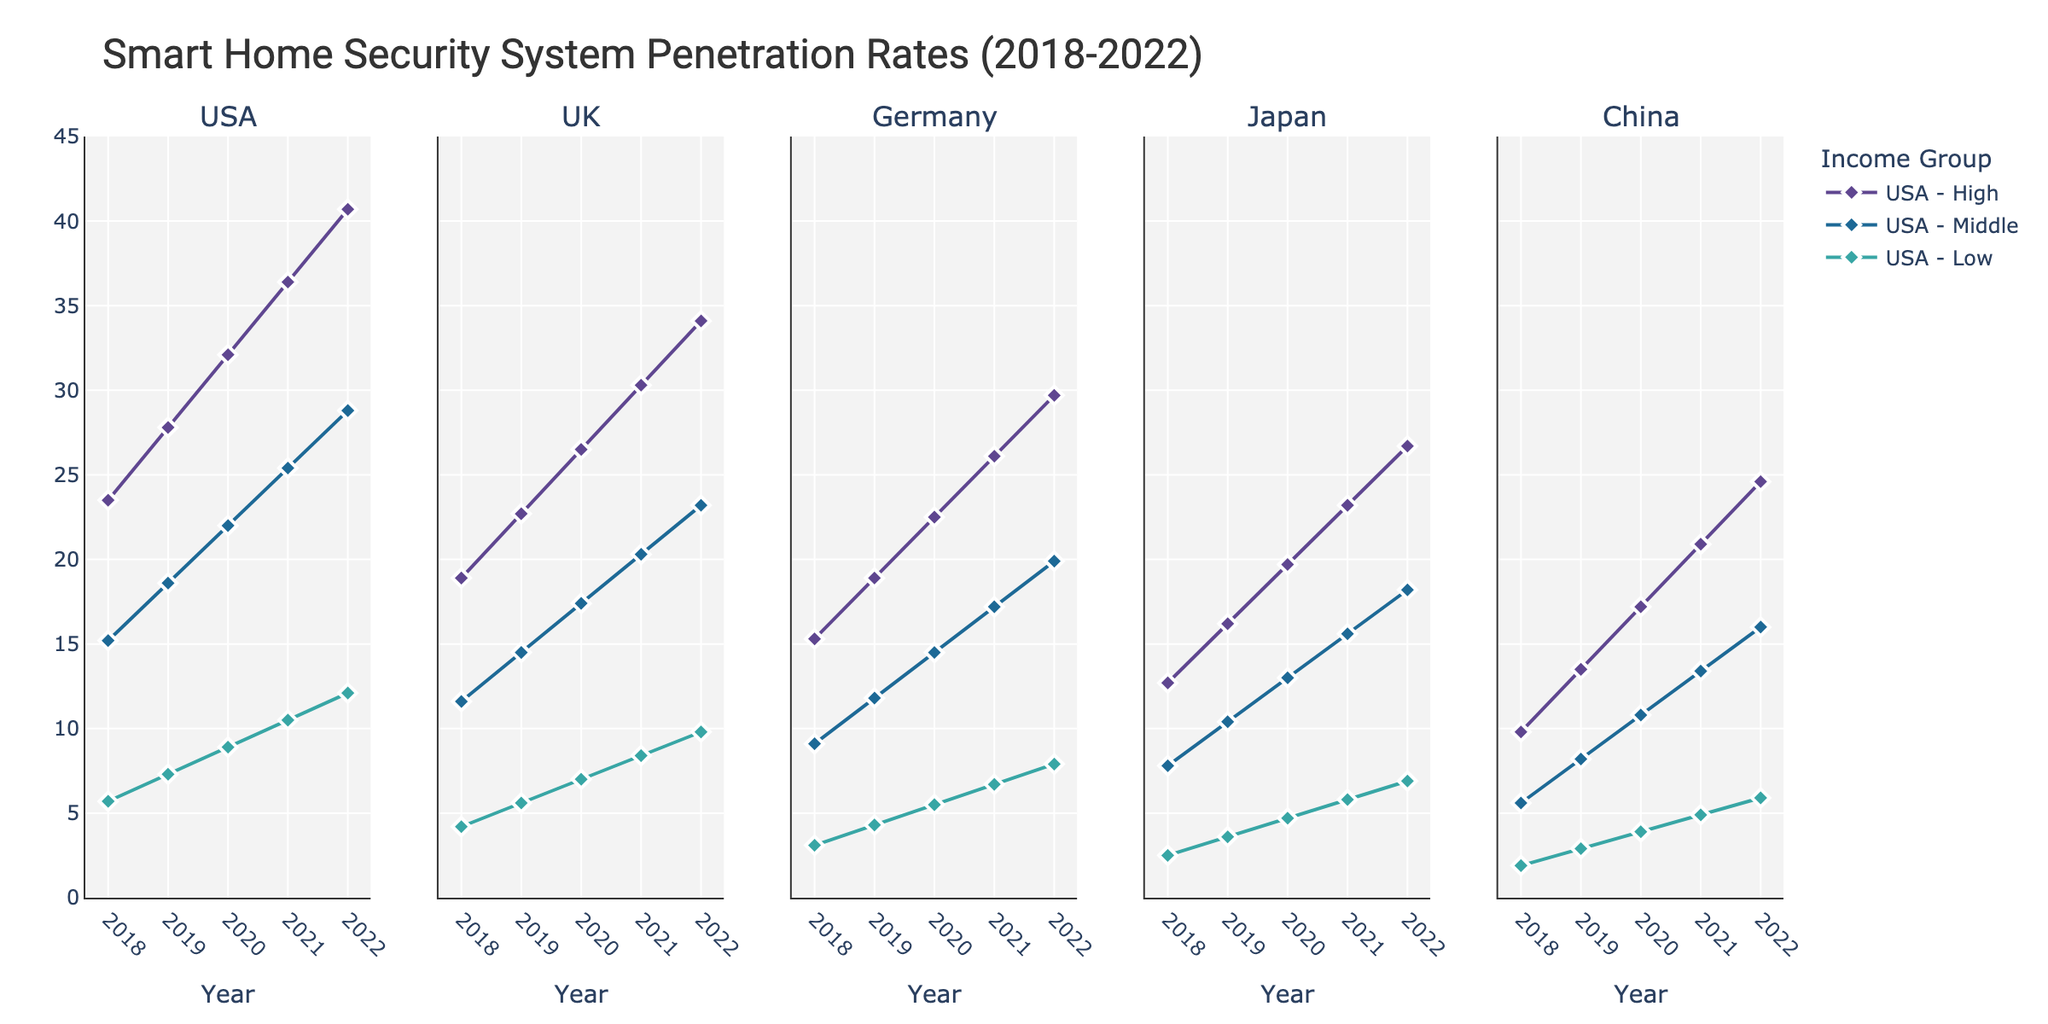Which country had the highest penetration rate in 2022 among high-income groups? To find the highest penetration rate for high-income groups in 2022, compare the endpoints of the lines labeled as high-income in each country subplot. The USA's high-income group reached a penetration rate of 40.7%, the highest among the countries.
Answer: USA From 2018 to 2022, which country's middle-income group showed the greatest percentage increase in penetration rate? Compute the percentage increase for each middle-income group's penetration rate between 2018 and 2022. For the USA: (28.8 - 15.2)/15.2 * 100 ≈ 89.47%; for the UK: (23.2 - 11.6)/11.6 * 100 ≈ 100%; for Germany: (19.9 - 9.1)/9.1 * 100 ≈ 118.68%; for Japan: (18.2 - 7.8)/7.8 * 100 ≈ 133.33%; for China: (16.0 - 5.6)/5.6 * 100 ≈ 185.71%. The highest increase is for China.
Answer: China By how much did the penetration rate in the low-income group in Germany increase from 2018 to 2022? Subtract the 2018 penetration rate from the 2022 penetration rate for Germany's low-income group: 7.9% - 3.1%.
Answer: 4.8% Which income group showed the steepest increase in penetration rate in the UK, and by how much did it increase? Identify the steepest line in the UK subplot, which corresponds to the high-income group. The increase from 2018 to 2022 for this group is 34.1% - 18.9%.
Answer: High-income, 15.2% In 2020, which country had the lowest penetration rate among all low-income groups? Compare the 2020 data points for all low-income groups. The lowest penetration rate in 2020 is found in China, with a penetration rate of 3.9%.
Answer: China What is the average penetration rate for the USA's middle-income group over the five years? Calculate the average by summing the penetration rates for the USA's middle-income group from 2018 to 2022 and then dividing by 5: (15.2 + 18.6 + 22.0 + 25.4 + 28.8)/5.
Answer: 22.0% Which country showed the least increase in smart home security penetration rates for middle-income groups between 2020 and 2022? Calculate the increase for each middle-income group between 2020 and 2022. The increase for the USA: 28.8 - 22.0 = 6.8; for the UK: 23.2 - 17.4 = 5.8; for Germany: 19.9 - 14.5 = 5.4; for Japan: 18.2 - 13.0 = 5.2; for China: 16.0 - 10.8 = 5.2. The least increases are for Japan and China, both 5.2.
Answer: Japan and China Among high-income groups, which country had the slowest growth rate from 2018 to 2021, and what was the growth rate? Calculate the growth rate for each high-income group from 2018 to 2021. USA: (36.4 - 23.5)/23.5 ≈ 54.89%; UK: (30.3 - 18.9)/18.9 ≈ 60.32%; Germany: (26.1 - 15.3)/15.3 ≈ 70.59%; Japan: (23.2 - 12.7)/12.7 ≈ 82.68%; China: (20.9 - 9.8)/9.8 ≈ 113.27%. The slowest growth rate is for the USA.
Answer: USA, 54.89% Which income group in Japan experienced a linear-like trend, and how can you describe it? Observe the Japan subplot for a line that shows a consistent, linear increase. The high-income group's line closely resembles a linear trend, increasing steadily each year.
Answer: High-income, linear steady increase 